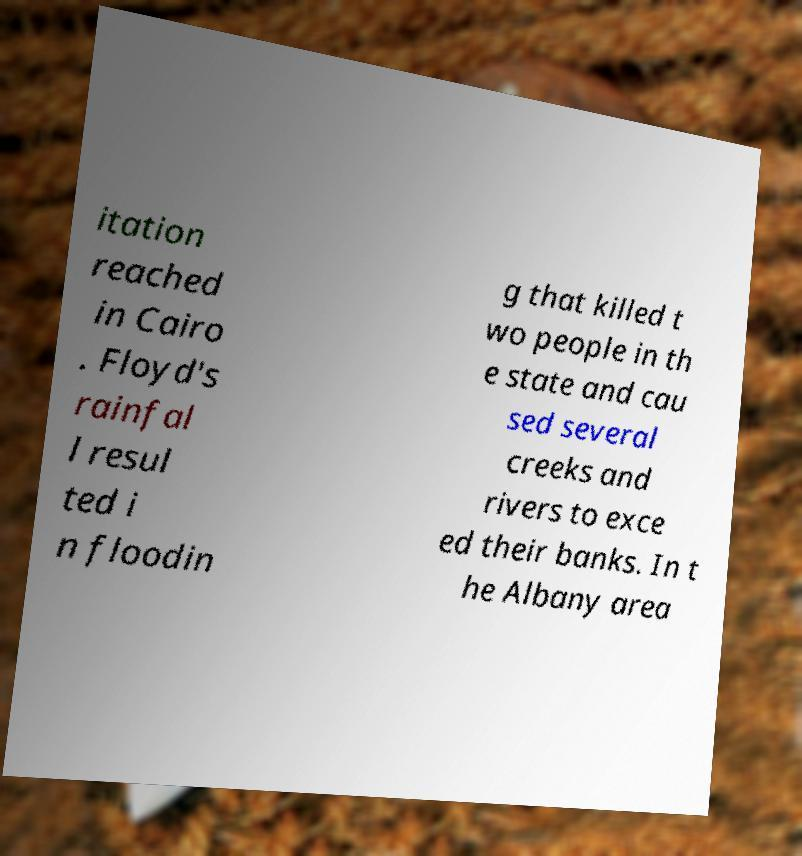Could you extract and type out the text from this image? itation reached in Cairo . Floyd's rainfal l resul ted i n floodin g that killed t wo people in th e state and cau sed several creeks and rivers to exce ed their banks. In t he Albany area 